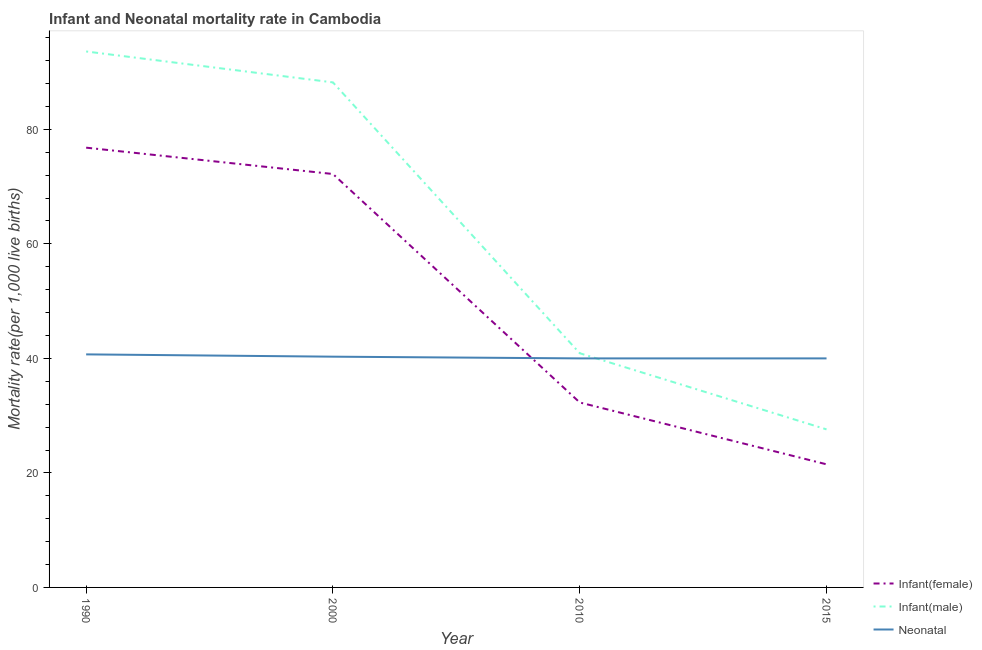How many different coloured lines are there?
Ensure brevity in your answer.  3. Does the line corresponding to infant mortality rate(female) intersect with the line corresponding to neonatal mortality rate?
Your answer should be very brief. Yes. Is the number of lines equal to the number of legend labels?
Offer a terse response. Yes. Across all years, what is the maximum neonatal mortality rate?
Provide a succinct answer. 40.7. In which year was the neonatal mortality rate maximum?
Give a very brief answer. 1990. In which year was the infant mortality rate(female) minimum?
Your response must be concise. 2015. What is the total infant mortality rate(male) in the graph?
Ensure brevity in your answer.  250.3. What is the difference between the infant mortality rate(female) in 2000 and that in 2010?
Keep it short and to the point. 39.9. What is the difference between the infant mortality rate(female) in 2010 and the infant mortality rate(male) in 2000?
Ensure brevity in your answer.  -55.9. What is the average infant mortality rate(female) per year?
Keep it short and to the point. 50.7. In the year 2015, what is the difference between the infant mortality rate(male) and infant mortality rate(female)?
Offer a very short reply. 6.1. What is the ratio of the neonatal mortality rate in 1990 to that in 2010?
Give a very brief answer. 1.02. Is the neonatal mortality rate in 2010 less than that in 2015?
Give a very brief answer. No. What is the difference between the highest and the second highest infant mortality rate(male)?
Give a very brief answer. 5.4. Is it the case that in every year, the sum of the infant mortality rate(female) and infant mortality rate(male) is greater than the neonatal mortality rate?
Keep it short and to the point. Yes. Does the neonatal mortality rate monotonically increase over the years?
Your answer should be compact. No. Is the infant mortality rate(female) strictly greater than the neonatal mortality rate over the years?
Your answer should be very brief. No. Is the infant mortality rate(female) strictly less than the infant mortality rate(male) over the years?
Keep it short and to the point. Yes. What is the difference between two consecutive major ticks on the Y-axis?
Your answer should be compact. 20. Does the graph contain any zero values?
Ensure brevity in your answer.  No. Does the graph contain grids?
Make the answer very short. No. Where does the legend appear in the graph?
Make the answer very short. Bottom right. How are the legend labels stacked?
Offer a very short reply. Vertical. What is the title of the graph?
Keep it short and to the point. Infant and Neonatal mortality rate in Cambodia. Does "Maunufacturing" appear as one of the legend labels in the graph?
Make the answer very short. No. What is the label or title of the Y-axis?
Ensure brevity in your answer.  Mortality rate(per 1,0 live births). What is the Mortality rate(per 1,000 live births) of Infant(female) in 1990?
Your answer should be very brief. 76.8. What is the Mortality rate(per 1,000 live births) in Infant(male) in 1990?
Your answer should be very brief. 93.6. What is the Mortality rate(per 1,000 live births) in Neonatal  in 1990?
Offer a terse response. 40.7. What is the Mortality rate(per 1,000 live births) of Infant(female) in 2000?
Provide a succinct answer. 72.2. What is the Mortality rate(per 1,000 live births) in Infant(male) in 2000?
Offer a terse response. 88.2. What is the Mortality rate(per 1,000 live births) of Neonatal  in 2000?
Provide a short and direct response. 40.3. What is the Mortality rate(per 1,000 live births) in Infant(female) in 2010?
Ensure brevity in your answer.  32.3. What is the Mortality rate(per 1,000 live births) in Infant(male) in 2010?
Make the answer very short. 40.9. What is the Mortality rate(per 1,000 live births) in Infant(male) in 2015?
Provide a short and direct response. 27.6. What is the Mortality rate(per 1,000 live births) of Neonatal  in 2015?
Your response must be concise. 40. Across all years, what is the maximum Mortality rate(per 1,000 live births) in Infant(female)?
Provide a succinct answer. 76.8. Across all years, what is the maximum Mortality rate(per 1,000 live births) of Infant(male)?
Keep it short and to the point. 93.6. Across all years, what is the maximum Mortality rate(per 1,000 live births) in Neonatal ?
Your answer should be very brief. 40.7. Across all years, what is the minimum Mortality rate(per 1,000 live births) of Infant(female)?
Offer a very short reply. 21.5. Across all years, what is the minimum Mortality rate(per 1,000 live births) of Infant(male)?
Make the answer very short. 27.6. Across all years, what is the minimum Mortality rate(per 1,000 live births) of Neonatal ?
Keep it short and to the point. 40. What is the total Mortality rate(per 1,000 live births) of Infant(female) in the graph?
Make the answer very short. 202.8. What is the total Mortality rate(per 1,000 live births) of Infant(male) in the graph?
Your answer should be compact. 250.3. What is the total Mortality rate(per 1,000 live births) of Neonatal  in the graph?
Keep it short and to the point. 161. What is the difference between the Mortality rate(per 1,000 live births) of Infant(female) in 1990 and that in 2000?
Your answer should be compact. 4.6. What is the difference between the Mortality rate(per 1,000 live births) in Infant(female) in 1990 and that in 2010?
Make the answer very short. 44.5. What is the difference between the Mortality rate(per 1,000 live births) of Infant(male) in 1990 and that in 2010?
Make the answer very short. 52.7. What is the difference between the Mortality rate(per 1,000 live births) of Infant(female) in 1990 and that in 2015?
Give a very brief answer. 55.3. What is the difference between the Mortality rate(per 1,000 live births) in Infant(male) in 1990 and that in 2015?
Your response must be concise. 66. What is the difference between the Mortality rate(per 1,000 live births) of Neonatal  in 1990 and that in 2015?
Provide a short and direct response. 0.7. What is the difference between the Mortality rate(per 1,000 live births) in Infant(female) in 2000 and that in 2010?
Your answer should be very brief. 39.9. What is the difference between the Mortality rate(per 1,000 live births) of Infant(male) in 2000 and that in 2010?
Your answer should be compact. 47.3. What is the difference between the Mortality rate(per 1,000 live births) in Infant(female) in 2000 and that in 2015?
Ensure brevity in your answer.  50.7. What is the difference between the Mortality rate(per 1,000 live births) in Infant(male) in 2000 and that in 2015?
Keep it short and to the point. 60.6. What is the difference between the Mortality rate(per 1,000 live births) of Infant(female) in 2010 and that in 2015?
Your response must be concise. 10.8. What is the difference between the Mortality rate(per 1,000 live births) of Infant(female) in 1990 and the Mortality rate(per 1,000 live births) of Neonatal  in 2000?
Make the answer very short. 36.5. What is the difference between the Mortality rate(per 1,000 live births) in Infant(male) in 1990 and the Mortality rate(per 1,000 live births) in Neonatal  in 2000?
Give a very brief answer. 53.3. What is the difference between the Mortality rate(per 1,000 live births) of Infant(female) in 1990 and the Mortality rate(per 1,000 live births) of Infant(male) in 2010?
Provide a succinct answer. 35.9. What is the difference between the Mortality rate(per 1,000 live births) in Infant(female) in 1990 and the Mortality rate(per 1,000 live births) in Neonatal  in 2010?
Keep it short and to the point. 36.8. What is the difference between the Mortality rate(per 1,000 live births) of Infant(male) in 1990 and the Mortality rate(per 1,000 live births) of Neonatal  in 2010?
Keep it short and to the point. 53.6. What is the difference between the Mortality rate(per 1,000 live births) of Infant(female) in 1990 and the Mortality rate(per 1,000 live births) of Infant(male) in 2015?
Ensure brevity in your answer.  49.2. What is the difference between the Mortality rate(per 1,000 live births) in Infant(female) in 1990 and the Mortality rate(per 1,000 live births) in Neonatal  in 2015?
Provide a succinct answer. 36.8. What is the difference between the Mortality rate(per 1,000 live births) of Infant(male) in 1990 and the Mortality rate(per 1,000 live births) of Neonatal  in 2015?
Give a very brief answer. 53.6. What is the difference between the Mortality rate(per 1,000 live births) of Infant(female) in 2000 and the Mortality rate(per 1,000 live births) of Infant(male) in 2010?
Offer a very short reply. 31.3. What is the difference between the Mortality rate(per 1,000 live births) in Infant(female) in 2000 and the Mortality rate(per 1,000 live births) in Neonatal  in 2010?
Provide a succinct answer. 32.2. What is the difference between the Mortality rate(per 1,000 live births) of Infant(male) in 2000 and the Mortality rate(per 1,000 live births) of Neonatal  in 2010?
Keep it short and to the point. 48.2. What is the difference between the Mortality rate(per 1,000 live births) of Infant(female) in 2000 and the Mortality rate(per 1,000 live births) of Infant(male) in 2015?
Offer a very short reply. 44.6. What is the difference between the Mortality rate(per 1,000 live births) of Infant(female) in 2000 and the Mortality rate(per 1,000 live births) of Neonatal  in 2015?
Your answer should be compact. 32.2. What is the difference between the Mortality rate(per 1,000 live births) in Infant(male) in 2000 and the Mortality rate(per 1,000 live births) in Neonatal  in 2015?
Your answer should be very brief. 48.2. What is the average Mortality rate(per 1,000 live births) in Infant(female) per year?
Offer a terse response. 50.7. What is the average Mortality rate(per 1,000 live births) of Infant(male) per year?
Ensure brevity in your answer.  62.58. What is the average Mortality rate(per 1,000 live births) of Neonatal  per year?
Provide a short and direct response. 40.25. In the year 1990, what is the difference between the Mortality rate(per 1,000 live births) of Infant(female) and Mortality rate(per 1,000 live births) of Infant(male)?
Give a very brief answer. -16.8. In the year 1990, what is the difference between the Mortality rate(per 1,000 live births) in Infant(female) and Mortality rate(per 1,000 live births) in Neonatal ?
Your answer should be very brief. 36.1. In the year 1990, what is the difference between the Mortality rate(per 1,000 live births) of Infant(male) and Mortality rate(per 1,000 live births) of Neonatal ?
Make the answer very short. 52.9. In the year 2000, what is the difference between the Mortality rate(per 1,000 live births) in Infant(female) and Mortality rate(per 1,000 live births) in Infant(male)?
Give a very brief answer. -16. In the year 2000, what is the difference between the Mortality rate(per 1,000 live births) of Infant(female) and Mortality rate(per 1,000 live births) of Neonatal ?
Offer a very short reply. 31.9. In the year 2000, what is the difference between the Mortality rate(per 1,000 live births) in Infant(male) and Mortality rate(per 1,000 live births) in Neonatal ?
Keep it short and to the point. 47.9. In the year 2010, what is the difference between the Mortality rate(per 1,000 live births) of Infant(female) and Mortality rate(per 1,000 live births) of Neonatal ?
Your answer should be compact. -7.7. In the year 2015, what is the difference between the Mortality rate(per 1,000 live births) of Infant(female) and Mortality rate(per 1,000 live births) of Infant(male)?
Offer a very short reply. -6.1. In the year 2015, what is the difference between the Mortality rate(per 1,000 live births) in Infant(female) and Mortality rate(per 1,000 live births) in Neonatal ?
Your response must be concise. -18.5. What is the ratio of the Mortality rate(per 1,000 live births) in Infant(female) in 1990 to that in 2000?
Your answer should be very brief. 1.06. What is the ratio of the Mortality rate(per 1,000 live births) of Infant(male) in 1990 to that in 2000?
Offer a terse response. 1.06. What is the ratio of the Mortality rate(per 1,000 live births) of Neonatal  in 1990 to that in 2000?
Offer a terse response. 1.01. What is the ratio of the Mortality rate(per 1,000 live births) in Infant(female) in 1990 to that in 2010?
Provide a short and direct response. 2.38. What is the ratio of the Mortality rate(per 1,000 live births) of Infant(male) in 1990 to that in 2010?
Offer a very short reply. 2.29. What is the ratio of the Mortality rate(per 1,000 live births) in Neonatal  in 1990 to that in 2010?
Keep it short and to the point. 1.02. What is the ratio of the Mortality rate(per 1,000 live births) of Infant(female) in 1990 to that in 2015?
Your response must be concise. 3.57. What is the ratio of the Mortality rate(per 1,000 live births) of Infant(male) in 1990 to that in 2015?
Offer a terse response. 3.39. What is the ratio of the Mortality rate(per 1,000 live births) in Neonatal  in 1990 to that in 2015?
Offer a very short reply. 1.02. What is the ratio of the Mortality rate(per 1,000 live births) of Infant(female) in 2000 to that in 2010?
Your response must be concise. 2.24. What is the ratio of the Mortality rate(per 1,000 live births) of Infant(male) in 2000 to that in 2010?
Your answer should be compact. 2.16. What is the ratio of the Mortality rate(per 1,000 live births) in Neonatal  in 2000 to that in 2010?
Make the answer very short. 1.01. What is the ratio of the Mortality rate(per 1,000 live births) of Infant(female) in 2000 to that in 2015?
Keep it short and to the point. 3.36. What is the ratio of the Mortality rate(per 1,000 live births) of Infant(male) in 2000 to that in 2015?
Provide a succinct answer. 3.2. What is the ratio of the Mortality rate(per 1,000 live births) of Neonatal  in 2000 to that in 2015?
Your answer should be very brief. 1.01. What is the ratio of the Mortality rate(per 1,000 live births) in Infant(female) in 2010 to that in 2015?
Your answer should be very brief. 1.5. What is the ratio of the Mortality rate(per 1,000 live births) in Infant(male) in 2010 to that in 2015?
Provide a succinct answer. 1.48. What is the ratio of the Mortality rate(per 1,000 live births) in Neonatal  in 2010 to that in 2015?
Make the answer very short. 1. What is the difference between the highest and the second highest Mortality rate(per 1,000 live births) in Infant(female)?
Your answer should be very brief. 4.6. What is the difference between the highest and the second highest Mortality rate(per 1,000 live births) of Infant(male)?
Your answer should be very brief. 5.4. What is the difference between the highest and the second highest Mortality rate(per 1,000 live births) in Neonatal ?
Offer a terse response. 0.4. What is the difference between the highest and the lowest Mortality rate(per 1,000 live births) of Infant(female)?
Your answer should be compact. 55.3. What is the difference between the highest and the lowest Mortality rate(per 1,000 live births) of Neonatal ?
Provide a succinct answer. 0.7. 